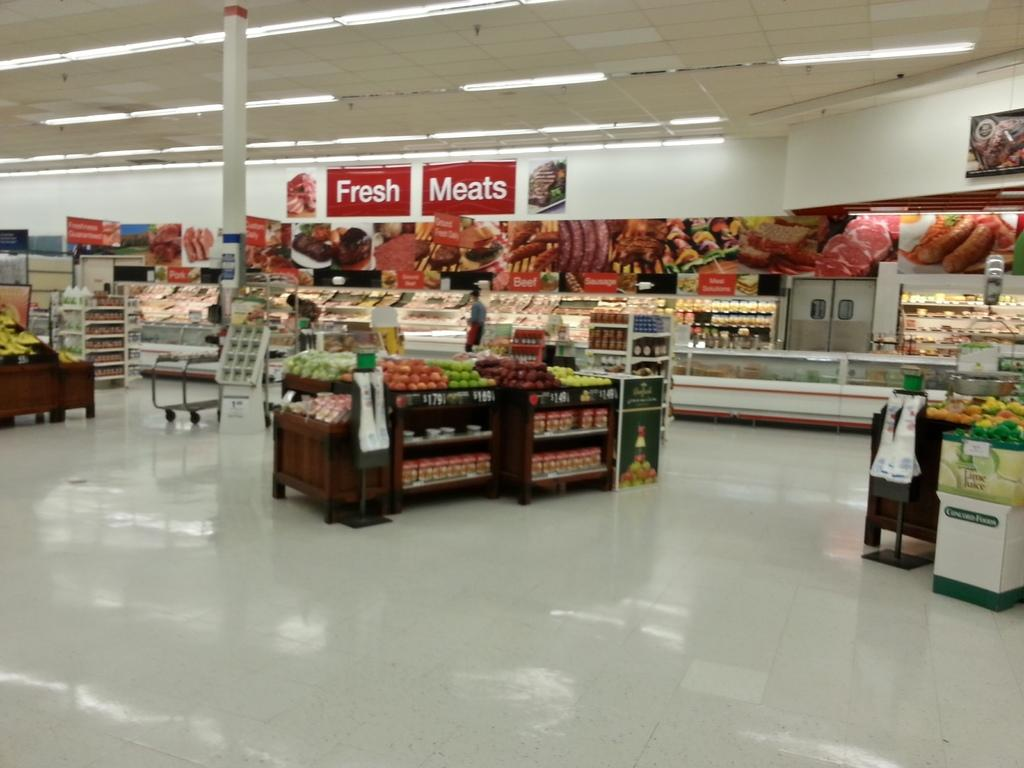<image>
Provide a brief description of the given image. The supermarket makes sure to advertise to the customers where the fresh meat is. 